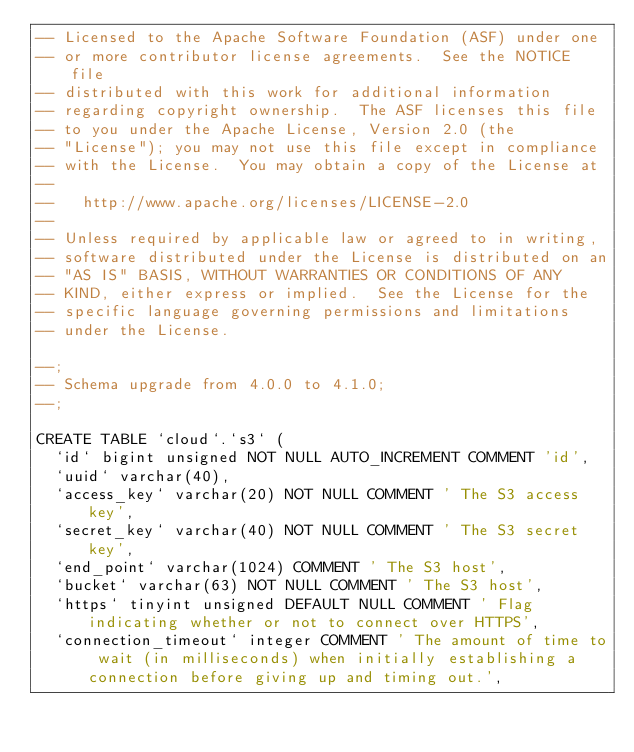<code> <loc_0><loc_0><loc_500><loc_500><_SQL_>-- Licensed to the Apache Software Foundation (ASF) under one
-- or more contributor license agreements.  See the NOTICE file
-- distributed with this work for additional information
-- regarding copyright ownership.  The ASF licenses this file
-- to you under the Apache License, Version 2.0 (the
-- "License"); you may not use this file except in compliance
-- with the License.  You may obtain a copy of the License at
--
--   http://www.apache.org/licenses/LICENSE-2.0
--
-- Unless required by applicable law or agreed to in writing,
-- software distributed under the License is distributed on an
-- "AS IS" BASIS, WITHOUT WARRANTIES OR CONDITIONS OF ANY
-- KIND, either express or implied.  See the License for the
-- specific language governing permissions and limitations
-- under the License.

--;
-- Schema upgrade from 4.0.0 to 4.1.0;
--;

CREATE TABLE `cloud`.`s3` (
  `id` bigint unsigned NOT NULL AUTO_INCREMENT COMMENT 'id',
  `uuid` varchar(40),
  `access_key` varchar(20) NOT NULL COMMENT ' The S3 access key',
  `secret_key` varchar(40) NOT NULL COMMENT ' The S3 secret key',
  `end_point` varchar(1024) COMMENT ' The S3 host',
  `bucket` varchar(63) NOT NULL COMMENT ' The S3 host',
  `https` tinyint unsigned DEFAULT NULL COMMENT ' Flag indicating whether or not to connect over HTTPS',
  `connection_timeout` integer COMMENT ' The amount of time to wait (in milliseconds) when initially establishing a connection before giving up and timing out.',</code> 